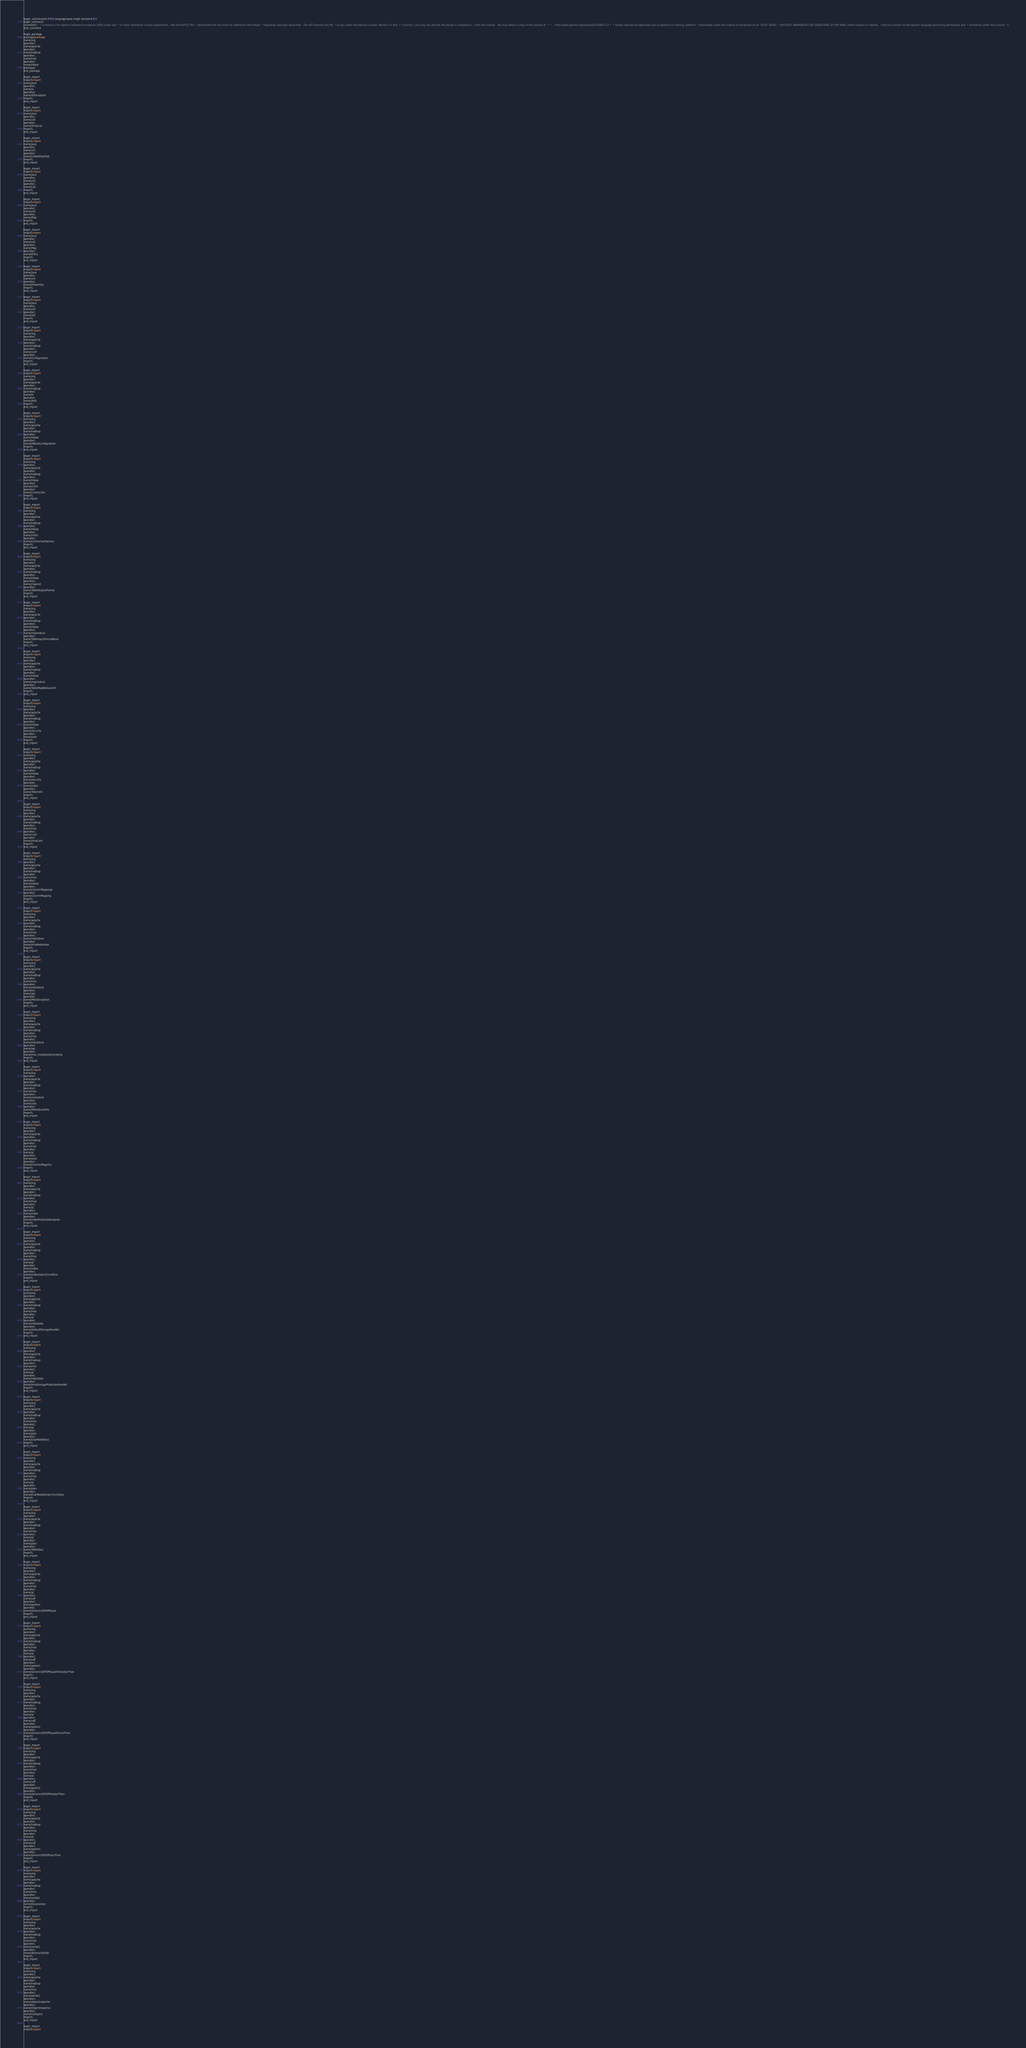<code> <loc_0><loc_0><loc_500><loc_500><_Java_>begin_unit|revision:0.9.5;language:Java;cregit-version:0.0.1
begin_comment
comment|/*  * Licensed to the Apache Software Foundation (ASF) under one  * or more contributor license agreements.  See the NOTICE file  * distributed with this work for additional information  * regarding copyright ownership.  The ASF licenses this file  * to you under the Apache License, Version 2.0 (the  * "License"); you may not use this file except in compliance  * with the License.  You may obtain a copy of the License at  *  *     http://www.apache.org/licenses/LICENSE-2.0  *  * Unless required by applicable law or agreed to in writing, software  * distributed under the License is distributed on an "AS IS" BASIS,  * WITHOUT WARRANTIES OR CONDITIONS OF ANY KIND, either express or implied.  * See the License for the specific language governing permissions and  * limitations under the License.  */
end_comment

begin_package
package|package
name|org
operator|.
name|apache
operator|.
name|hadoop
operator|.
name|hive
operator|.
name|hbase
package|;
end_package

begin_import
import|import
name|java
operator|.
name|io
operator|.
name|IOException
import|;
end_import

begin_import
import|import
name|java
operator|.
name|util
operator|.
name|ArrayList
import|;
end_import

begin_import
import|import
name|java
operator|.
name|util
operator|.
name|LinkedHashSet
import|;
end_import

begin_import
import|import
name|java
operator|.
name|util
operator|.
name|List
import|;
end_import

begin_import
import|import
name|java
operator|.
name|util
operator|.
name|Map
import|;
end_import

begin_import
import|import
name|java
operator|.
name|util
operator|.
name|Map
operator|.
name|Entry
import|;
end_import

begin_import
import|import
name|java
operator|.
name|util
operator|.
name|Properties
import|;
end_import

begin_import
import|import
name|java
operator|.
name|util
operator|.
name|Set
import|;
end_import

begin_import
import|import
name|org
operator|.
name|apache
operator|.
name|hadoop
operator|.
name|conf
operator|.
name|Configuration
import|;
end_import

begin_import
import|import
name|org
operator|.
name|apache
operator|.
name|hadoop
operator|.
name|fs
operator|.
name|Path
import|;
end_import

begin_import
import|import
name|org
operator|.
name|apache
operator|.
name|hadoop
operator|.
name|hbase
operator|.
name|HBaseConfiguration
import|;
end_import

begin_import
import|import
name|org
operator|.
name|apache
operator|.
name|hadoop
operator|.
name|hbase
operator|.
name|client
operator|.
name|Connection
import|;
end_import

begin_import
import|import
name|org
operator|.
name|apache
operator|.
name|hadoop
operator|.
name|hbase
operator|.
name|client
operator|.
name|ConnectionFactory
import|;
end_import

begin_import
import|import
name|org
operator|.
name|apache
operator|.
name|hadoop
operator|.
name|hbase
operator|.
name|mapred
operator|.
name|TableOutputFormat
import|;
end_import

begin_import
import|import
name|org
operator|.
name|apache
operator|.
name|hadoop
operator|.
name|hbase
operator|.
name|mapreduce
operator|.
name|TableInputFormatBase
import|;
end_import

begin_import
import|import
name|org
operator|.
name|apache
operator|.
name|hadoop
operator|.
name|hbase
operator|.
name|mapreduce
operator|.
name|TableMapReduceUtil
import|;
end_import

begin_import
import|import
name|org
operator|.
name|apache
operator|.
name|hadoop
operator|.
name|hbase
operator|.
name|security
operator|.
name|User
import|;
end_import

begin_import
import|import
name|org
operator|.
name|apache
operator|.
name|hadoop
operator|.
name|hbase
operator|.
name|security
operator|.
name|token
operator|.
name|TokenUtil
import|;
end_import

begin_import
import|import
name|org
operator|.
name|apache
operator|.
name|hadoop
operator|.
name|hive
operator|.
name|conf
operator|.
name|HiveConf
import|;
end_import

begin_import
import|import
name|org
operator|.
name|apache
operator|.
name|hadoop
operator|.
name|hive
operator|.
name|hbase
operator|.
name|ColumnMappings
operator|.
name|ColumnMapping
import|;
end_import

begin_import
import|import
name|org
operator|.
name|apache
operator|.
name|hadoop
operator|.
name|hive
operator|.
name|metastore
operator|.
name|HiveMetaHook
import|;
end_import

begin_import
import|import
name|org
operator|.
name|apache
operator|.
name|hadoop
operator|.
name|hive
operator|.
name|metastore
operator|.
name|api
operator|.
name|MetaException
import|;
end_import

begin_import
import|import
name|org
operator|.
name|apache
operator|.
name|hadoop
operator|.
name|hive
operator|.
name|metastore
operator|.
name|api
operator|.
name|hive_metastoreConstants
import|;
end_import

begin_import
import|import
name|org
operator|.
name|apache
operator|.
name|hadoop
operator|.
name|hive
operator|.
name|metastore
operator|.
name|utils
operator|.
name|MetaStoreUtils
import|;
end_import

begin_import
import|import
name|org
operator|.
name|apache
operator|.
name|hadoop
operator|.
name|hive
operator|.
name|ql
operator|.
name|exec
operator|.
name|FunctionRegistry
import|;
end_import

begin_import
import|import
name|org
operator|.
name|apache
operator|.
name|hadoop
operator|.
name|hive
operator|.
name|ql
operator|.
name|index
operator|.
name|IndexPredicateAnalyzer
import|;
end_import

begin_import
import|import
name|org
operator|.
name|apache
operator|.
name|hadoop
operator|.
name|hive
operator|.
name|ql
operator|.
name|index
operator|.
name|IndexSearchCondition
import|;
end_import

begin_import
import|import
name|org
operator|.
name|apache
operator|.
name|hadoop
operator|.
name|hive
operator|.
name|ql
operator|.
name|metadata
operator|.
name|DefaultStorageHandler
import|;
end_import

begin_import
import|import
name|org
operator|.
name|apache
operator|.
name|hadoop
operator|.
name|hive
operator|.
name|ql
operator|.
name|metadata
operator|.
name|HiveStoragePredicateHandler
import|;
end_import

begin_import
import|import
name|org
operator|.
name|apache
operator|.
name|hadoop
operator|.
name|hive
operator|.
name|ql
operator|.
name|plan
operator|.
name|ExprNodeDesc
import|;
end_import

begin_import
import|import
name|org
operator|.
name|apache
operator|.
name|hadoop
operator|.
name|hive
operator|.
name|ql
operator|.
name|plan
operator|.
name|ExprNodeGenericFuncDesc
import|;
end_import

begin_import
import|import
name|org
operator|.
name|apache
operator|.
name|hadoop
operator|.
name|hive
operator|.
name|ql
operator|.
name|plan
operator|.
name|TableDesc
import|;
end_import

begin_import
import|import
name|org
operator|.
name|apache
operator|.
name|hadoop
operator|.
name|hive
operator|.
name|ql
operator|.
name|udf
operator|.
name|generic
operator|.
name|GenericUDFOPEqual
import|;
end_import

begin_import
import|import
name|org
operator|.
name|apache
operator|.
name|hadoop
operator|.
name|hive
operator|.
name|ql
operator|.
name|udf
operator|.
name|generic
operator|.
name|GenericUDFOPEqualOrGreaterThan
import|;
end_import

begin_import
import|import
name|org
operator|.
name|apache
operator|.
name|hadoop
operator|.
name|hive
operator|.
name|ql
operator|.
name|udf
operator|.
name|generic
operator|.
name|GenericUDFOPEqualOrLessThan
import|;
end_import

begin_import
import|import
name|org
operator|.
name|apache
operator|.
name|hadoop
operator|.
name|hive
operator|.
name|ql
operator|.
name|udf
operator|.
name|generic
operator|.
name|GenericUDFOPGreaterThan
import|;
end_import

begin_import
import|import
name|org
operator|.
name|apache
operator|.
name|hadoop
operator|.
name|hive
operator|.
name|ql
operator|.
name|udf
operator|.
name|generic
operator|.
name|GenericUDFOPLessThan
import|;
end_import

begin_import
import|import
name|org
operator|.
name|apache
operator|.
name|hadoop
operator|.
name|hive
operator|.
name|serde2
operator|.
name|Deserializer
import|;
end_import

begin_import
import|import
name|org
operator|.
name|apache
operator|.
name|hadoop
operator|.
name|hive
operator|.
name|serde2
operator|.
name|AbstractSerDe
import|;
end_import

begin_import
import|import
name|org
operator|.
name|apache
operator|.
name|hadoop
operator|.
name|hive
operator|.
name|serde2
operator|.
name|objectinspector
operator|.
name|ObjectInspector
operator|.
name|Category
import|;
end_import

begin_import
import|import</code> 